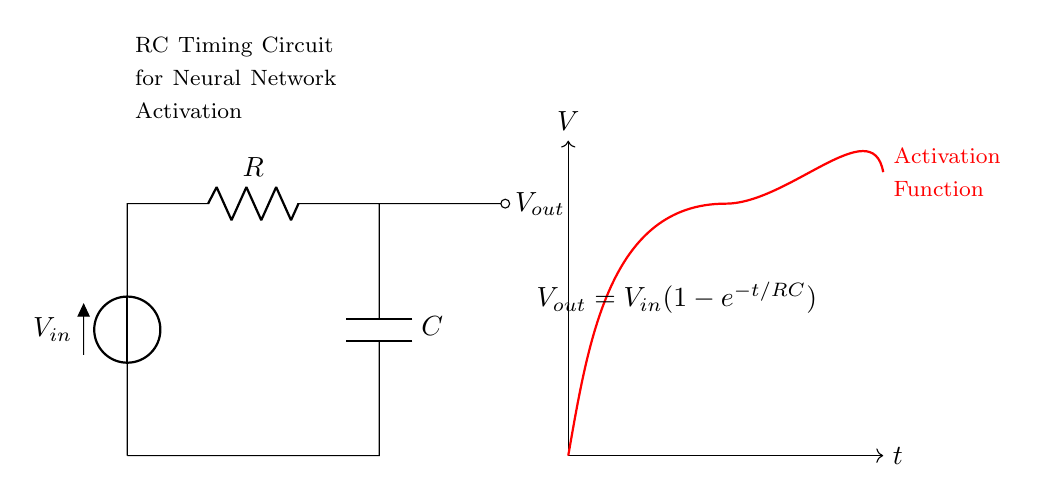What are the components in this circuit? The diagram indicates there are a voltage source, a resistor, and a capacitor, which are the essential components in an RC timing circuit.
Answer: voltage source, resistor, capacitor What is the function of the capacitor in this RC circuit? The capacitor in this circuit stores electrical energy and releases it over time, which is key in determining how the output voltage changes as a function of time, especially in timing applications.
Answer: stores energy What is the output voltage expression of this circuit? The output voltage expression for this RC timing circuit is given as V out equals V in times (1 minus e to the power of negative t over RC). This indicates how the output voltage evolves over time.
Answer: V out = V in (1 - e^(-t/RC)) How does the resistor affect the timing of the output voltage? The resistor controls the rate at which the capacitor charges, influencing the time constant denoted as tau, which is the product of resistance and capacitance, R times C; this time constant dictates how quickly the output voltage approaches its final value.
Answer: time constant What is the voltage across the capacitor after one time constant? At one time constant, which is equal to R times C, the voltage across the capacitor reaches approximately 63.2% of the input voltage, showcasing the charging behavior of the circuit.
Answer: 63.2% of V in What happens to the output voltage as time approaches infinity? As time approaches infinity, the output voltage will approach the input voltage, indicating that the capacitor becomes fully charged and there are no further changes in voltage across its terminals.
Answer: V in What role does the RC timing circuit play in neural networks? The RC timing circuit can be utilized in neural networks to implement activation functions that mimic biological processes, controlling how signals propagate and influence the learning behavior.
Answer: implement activation functions 